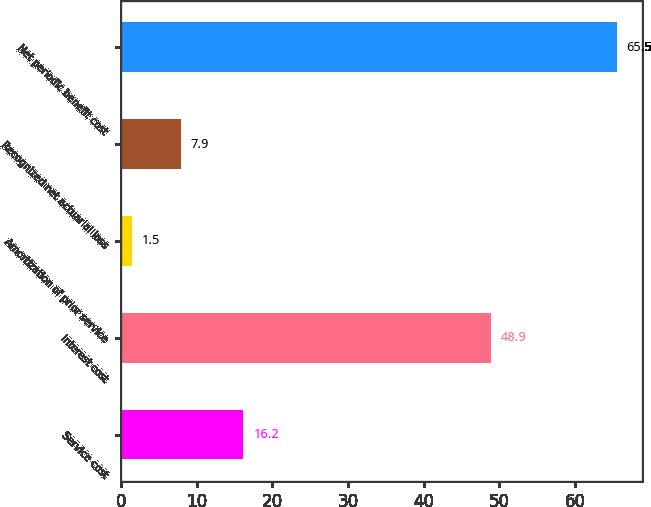<chart> <loc_0><loc_0><loc_500><loc_500><bar_chart><fcel>Service cost<fcel>Interest cost<fcel>Amortization of prior service<fcel>Recognized net actuarial loss<fcel>Net periodic benefit cost<nl><fcel>16.2<fcel>48.9<fcel>1.5<fcel>7.9<fcel>65.5<nl></chart> 